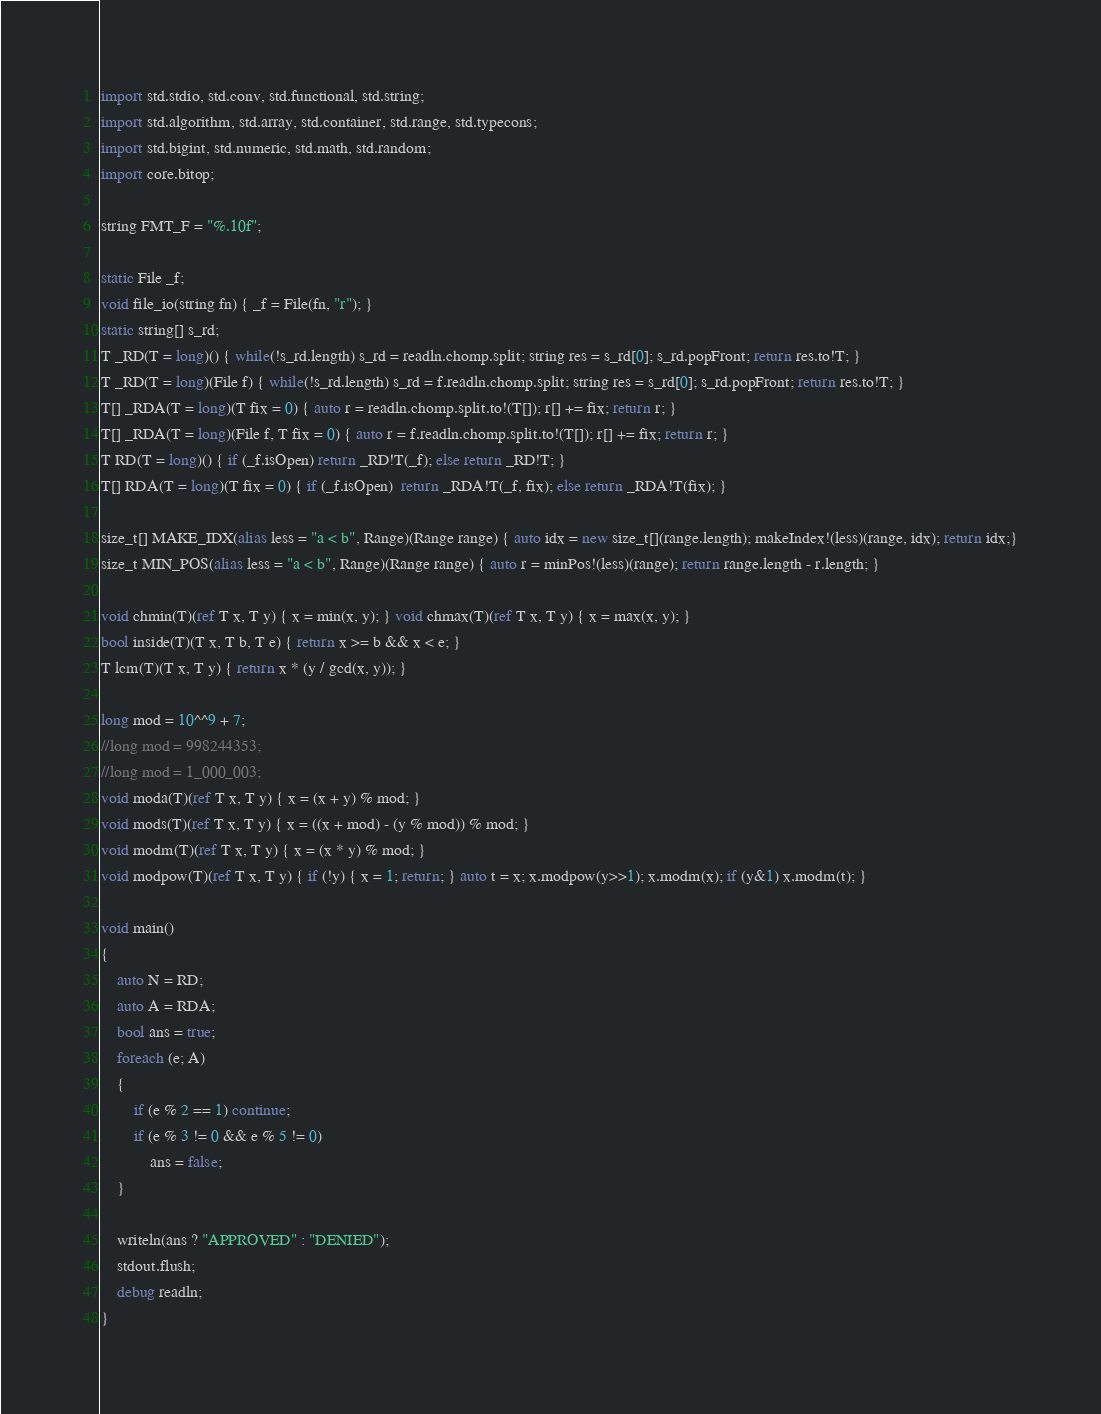<code> <loc_0><loc_0><loc_500><loc_500><_D_>import std.stdio, std.conv, std.functional, std.string;
import std.algorithm, std.array, std.container, std.range, std.typecons;
import std.bigint, std.numeric, std.math, std.random;
import core.bitop;

string FMT_F = "%.10f";

static File _f;
void file_io(string fn) { _f = File(fn, "r"); }
static string[] s_rd;
T _RD(T = long)() { while(!s_rd.length) s_rd = readln.chomp.split; string res = s_rd[0]; s_rd.popFront; return res.to!T; }
T _RD(T = long)(File f) { while(!s_rd.length) s_rd = f.readln.chomp.split; string res = s_rd[0]; s_rd.popFront; return res.to!T; }
T[] _RDA(T = long)(T fix = 0) { auto r = readln.chomp.split.to!(T[]); r[] += fix; return r; }
T[] _RDA(T = long)(File f, T fix = 0) { auto r = f.readln.chomp.split.to!(T[]); r[] += fix; return r; }
T RD(T = long)() { if (_f.isOpen) return _RD!T(_f); else return _RD!T; }
T[] RDA(T = long)(T fix = 0) { if (_f.isOpen)  return _RDA!T(_f, fix); else return _RDA!T(fix); }

size_t[] MAKE_IDX(alias less = "a < b", Range)(Range range) { auto idx = new size_t[](range.length); makeIndex!(less)(range, idx); return idx;}
size_t MIN_POS(alias less = "a < b", Range)(Range range) { auto r = minPos!(less)(range); return range.length - r.length; }

void chmin(T)(ref T x, T y) { x = min(x, y); } void chmax(T)(ref T x, T y) { x = max(x, y); }
bool inside(T)(T x, T b, T e) { return x >= b && x < e; }
T lcm(T)(T x, T y) { return x * (y / gcd(x, y)); }

long mod = 10^^9 + 7;
//long mod = 998244353;
//long mod = 1_000_003;
void moda(T)(ref T x, T y) { x = (x + y) % mod; }
void mods(T)(ref T x, T y) { x = ((x + mod) - (y % mod)) % mod; }
void modm(T)(ref T x, T y) { x = (x * y) % mod; }
void modpow(T)(ref T x, T y) { if (!y) { x = 1; return; } auto t = x; x.modpow(y>>1); x.modm(x); if (y&1) x.modm(t); }

void main()
{
	auto N = RD;
	auto A = RDA;
	bool ans = true;
	foreach (e; A)
	{
		if (e % 2 == 1) continue;
		if (e % 3 != 0 && e % 5 != 0)
			ans = false;
	}

	writeln(ans ? "APPROVED" : "DENIED");
	stdout.flush;
	debug readln;
}</code> 